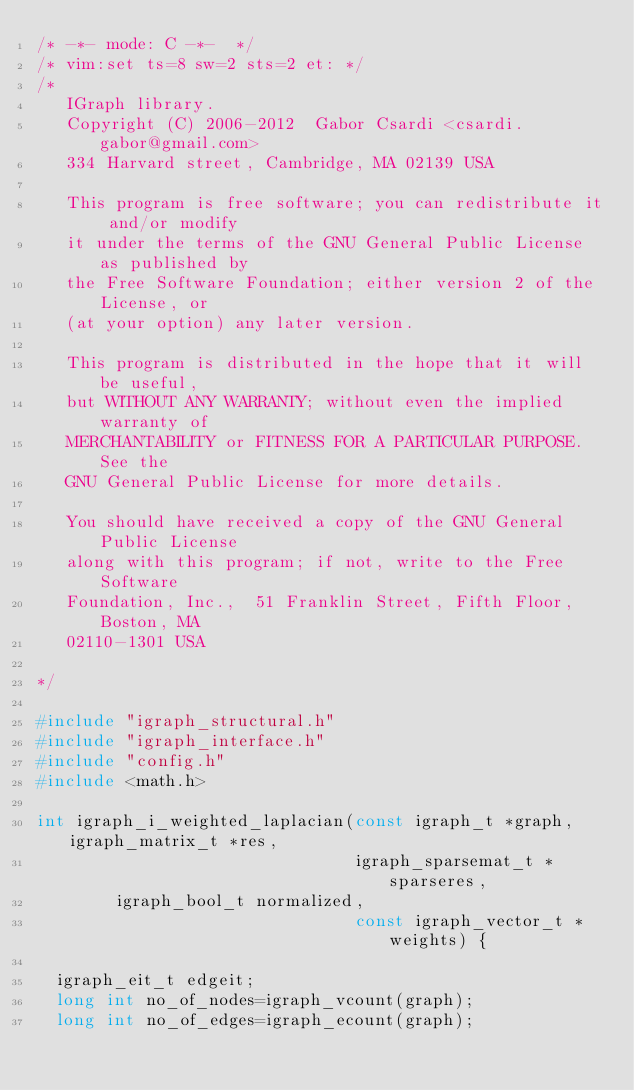Convert code to text. <code><loc_0><loc_0><loc_500><loc_500><_C_>/* -*- mode: C -*-  */
/* vim:set ts=8 sw=2 sts=2 et: */
/* 
   IGraph library.
   Copyright (C) 2006-2012  Gabor Csardi <csardi.gabor@gmail.com>
   334 Harvard street, Cambridge, MA 02139 USA
   
   This program is free software; you can redistribute it and/or modify
   it under the terms of the GNU General Public License as published by
   the Free Software Foundation; either version 2 of the License, or
   (at your option) any later version.
   
   This program is distributed in the hope that it will be useful,
   but WITHOUT ANY WARRANTY; without even the implied warranty of
   MERCHANTABILITY or FITNESS FOR A PARTICULAR PURPOSE.  See the
   GNU General Public License for more details.
   
   You should have received a copy of the GNU General Public License
   along with this program; if not, write to the Free Software
   Foundation, Inc.,  51 Franklin Street, Fifth Floor, Boston, MA 
   02110-1301 USA

*/

#include "igraph_structural.h"
#include "igraph_interface.h"
#include "config.h"
#include <math.h>

int igraph_i_weighted_laplacian(const igraph_t *graph, igraph_matrix_t *res,
                                igraph_sparsemat_t *sparseres,
				igraph_bool_t normalized, 
                                const igraph_vector_t *weights) {
  
  igraph_eit_t edgeit;
  long int no_of_nodes=igraph_vcount(graph);
  long int no_of_edges=igraph_ecount(graph);</code> 